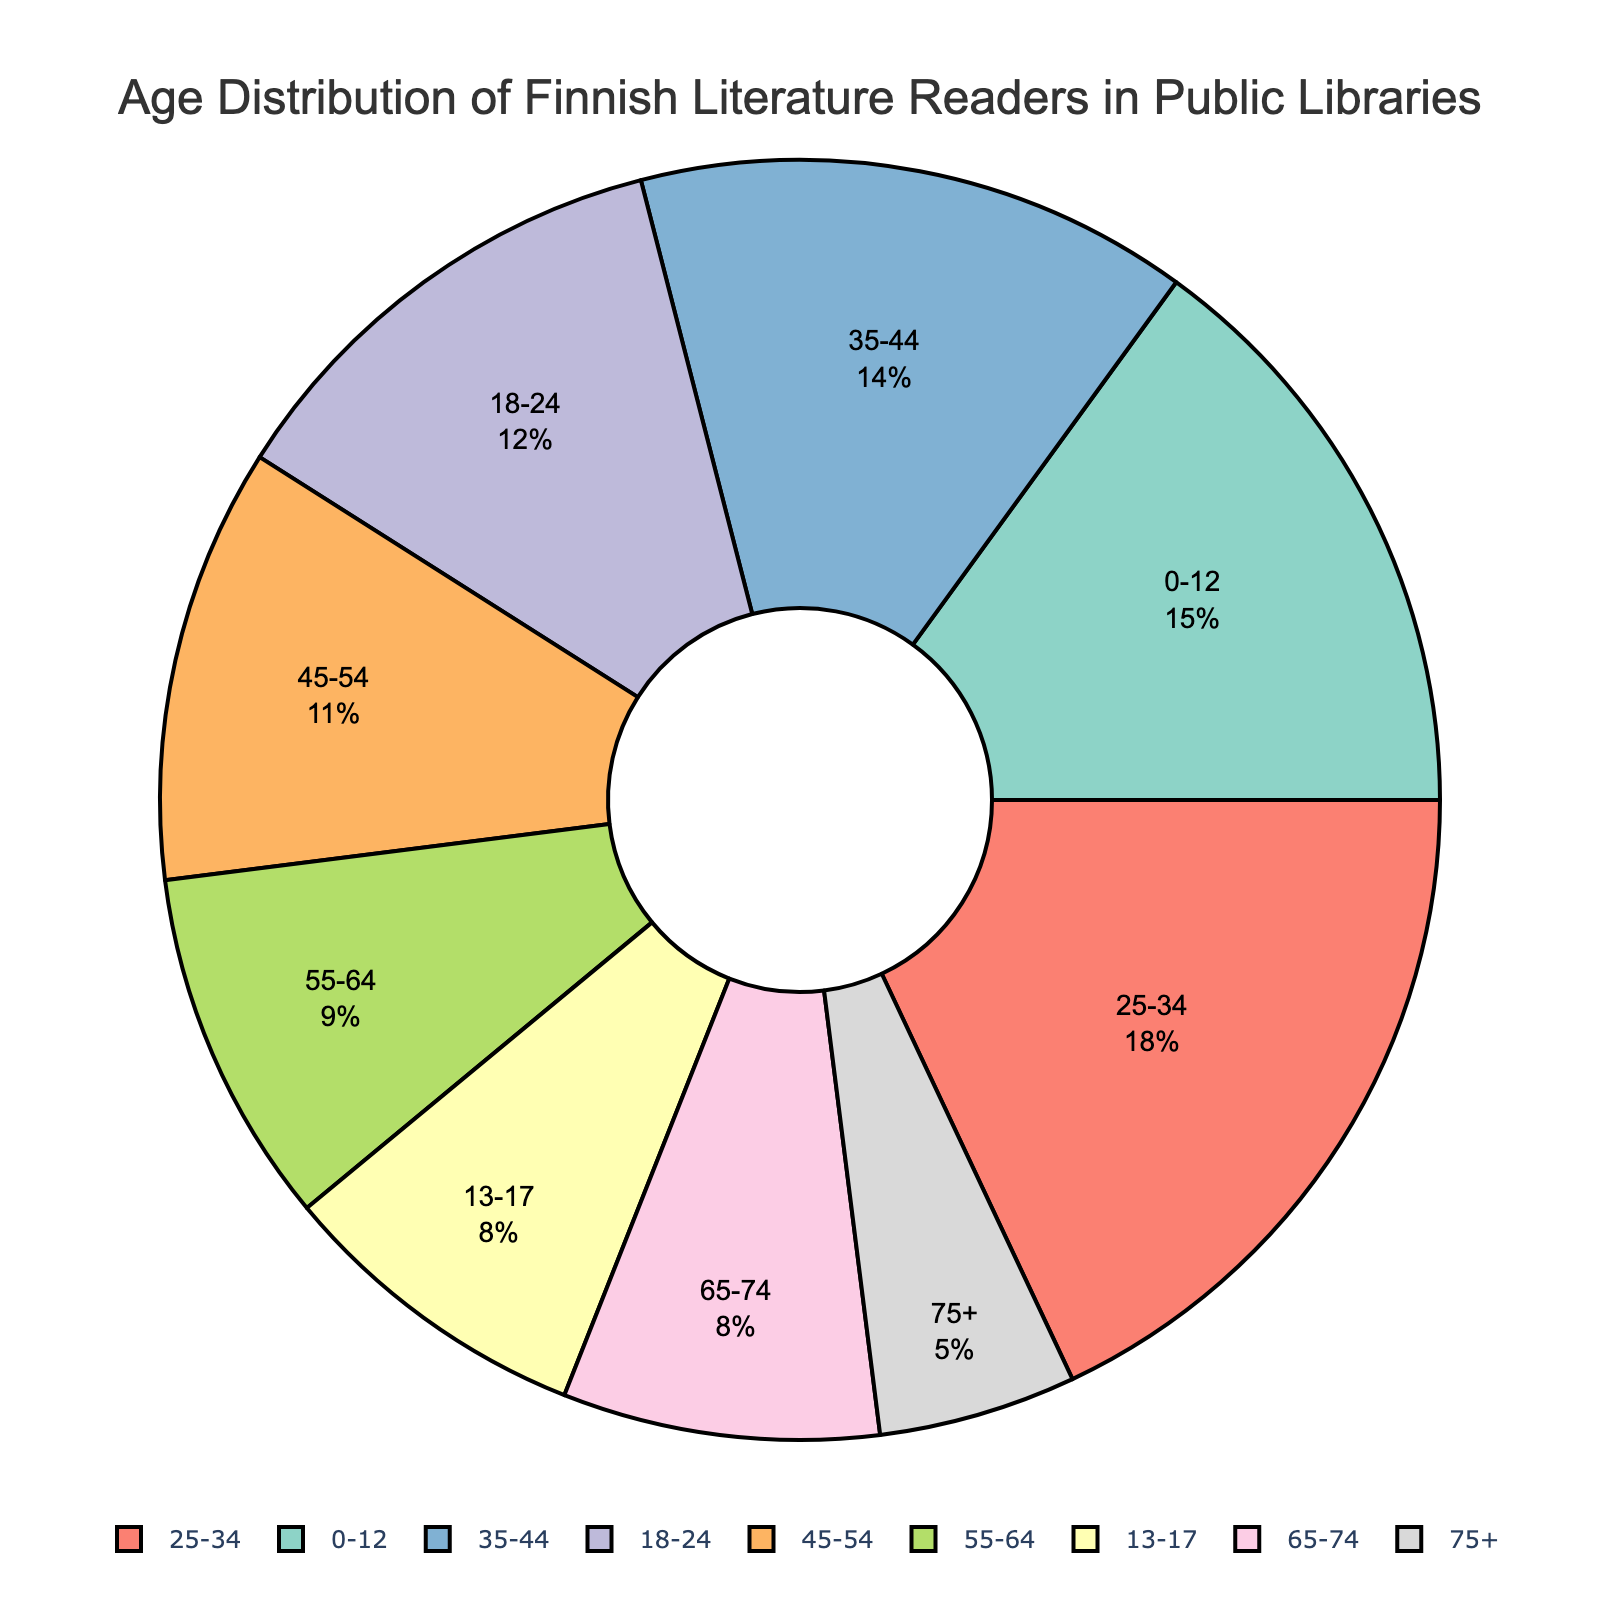Which age group has the highest percentage of Finnish literature readers? The age group with the highest percentage on the pie chart has a larger proportion of the total. According to the chart, the 25-34 age group has the highest percentage.
Answer: 25-34 What is the combined percentage of readers aged 55 and above? To find the combined percentage of readers aged 55 and above, sum the percentages of the 55-64, 65-74, and 75+ age groups: 9% + 8% + 5% = 22%.
Answer: 22% Which two age groups have the same percentage of Finnish literature readers? By inspecting the pie chart, the 13-17 and 65-74 age groups both have percentages of 8%.
Answer: 13-17 and 65-74 How much higher is the percentage of readers aged 0-12 compared to those aged 75+? Subtract the percentage of the 75+ age group from the percentage of the 0-12 age group: 15% - 5% = 10%.
Answer: 10% What percentage of readers are in the 18-44 age range? To find the percentage of readers aged 18-44, sum the percentages of the 18-24, 25-34, and 35-44 age groups: 12% + 18% + 14% = 44%.
Answer: 44% Which age group is represented by the color blue in the pie chart? The visual inspection of the pie chart shows that the 35-44 age group is represented by the color blue.
Answer: 35-44 Is the percentage of readers aged 35-44 greater or less than the percentage of readers aged 0-12? By comparing the percentages, the 35-44 age group (14%) is less than the 0-12 age group (15%).
Answer: Less What is the difference in percentage between the 25-34 age group and the 45-54 age group? Subtract the percentage of the 45-54 age group from the 25-34 age group: 18% - 11% = 7%.
Answer: 7% Which age groups each account for less than 10% of the readership? The age groups with less than 10% are the 13-17, 55-64, 65-74, and 75+ age groups, shown to have 8%, 9%, 8%, and 5% respectively.
Answer: 13-17, 55-64, 65-74, 75+ Are there more readers aged 25-34 or combined readers aged 45-64? Combine the percentages of the 45-54 and 55-64 age groups: 11% + 9% = 20%. Since 20% (combined 45-64) is greater than 18% (25-34), there are more combined readers aged 45-64.
Answer: Combined 45-64 